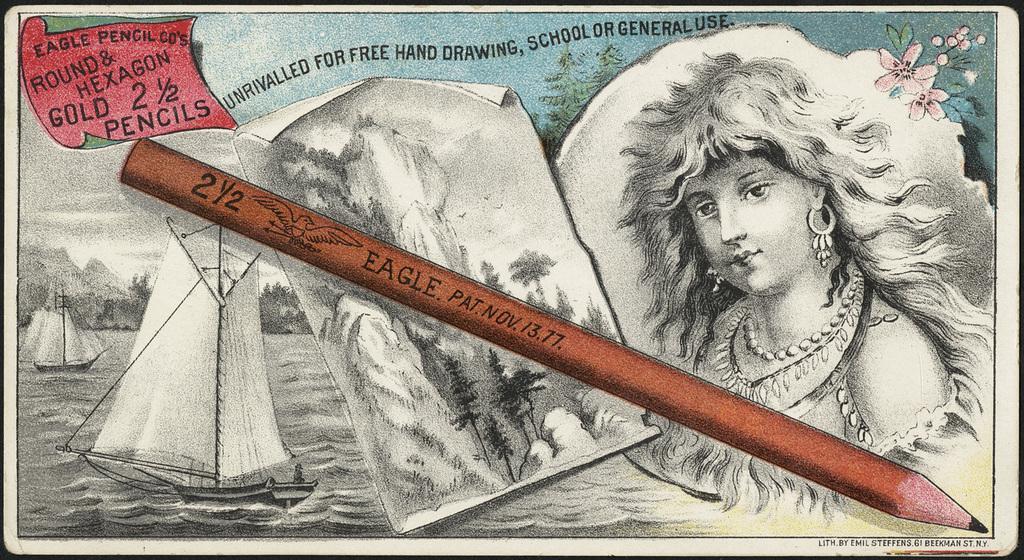In one or two sentences, can you explain what this image depicts? In this image there is a painting, in the painting there are boats in the water, sketch of a woman, flower, trees, text, a pencil with some text on it and mountains. At the bottom of the image there is some text.  